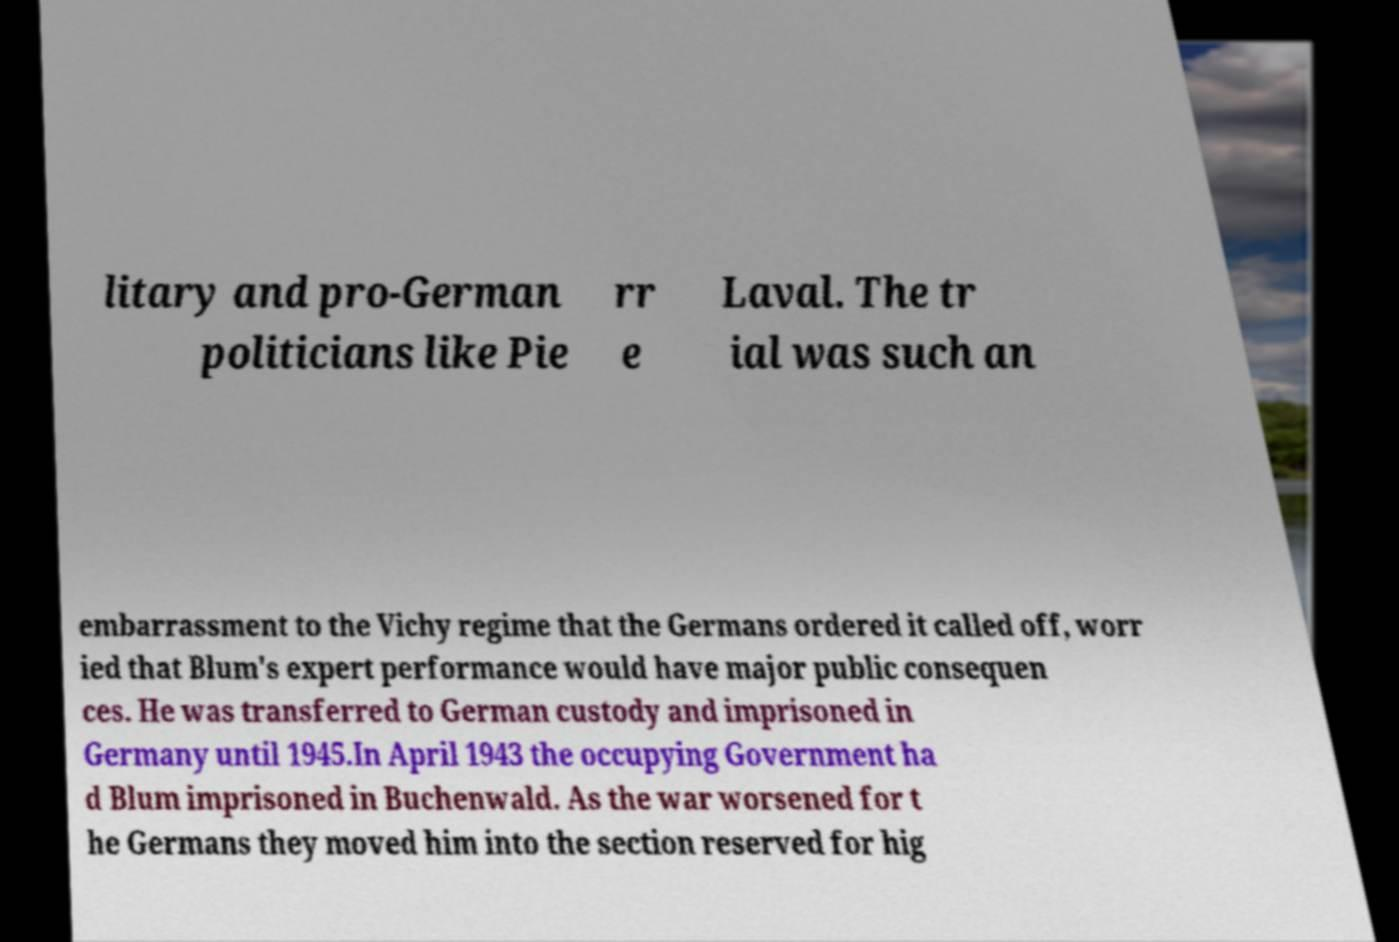Could you assist in decoding the text presented in this image and type it out clearly? litary and pro-German politicians like Pie rr e Laval. The tr ial was such an embarrassment to the Vichy regime that the Germans ordered it called off, worr ied that Blum's expert performance would have major public consequen ces. He was transferred to German custody and imprisoned in Germany until 1945.In April 1943 the occupying Government ha d Blum imprisoned in Buchenwald. As the war worsened for t he Germans they moved him into the section reserved for hig 